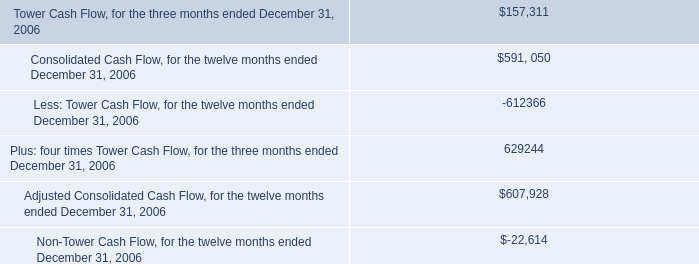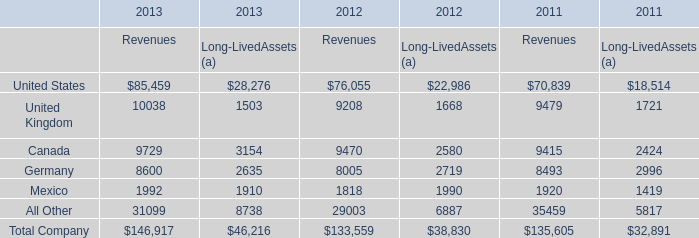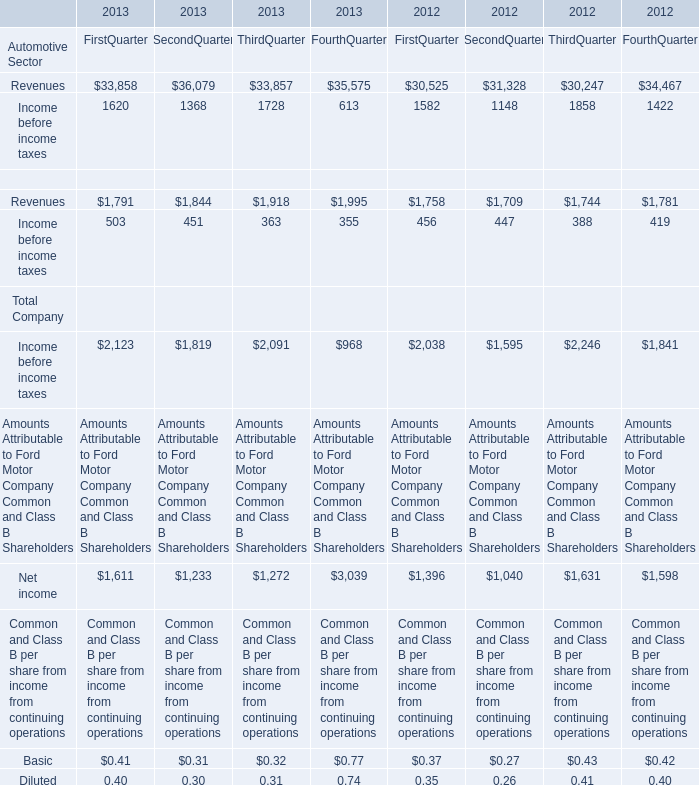In the year with largest amount of United kingdom of revenues, what's the increasing rate of Germany? (in %) 
Computations: ((8600 - 8005) / 8005)
Answer: 0.07433. 